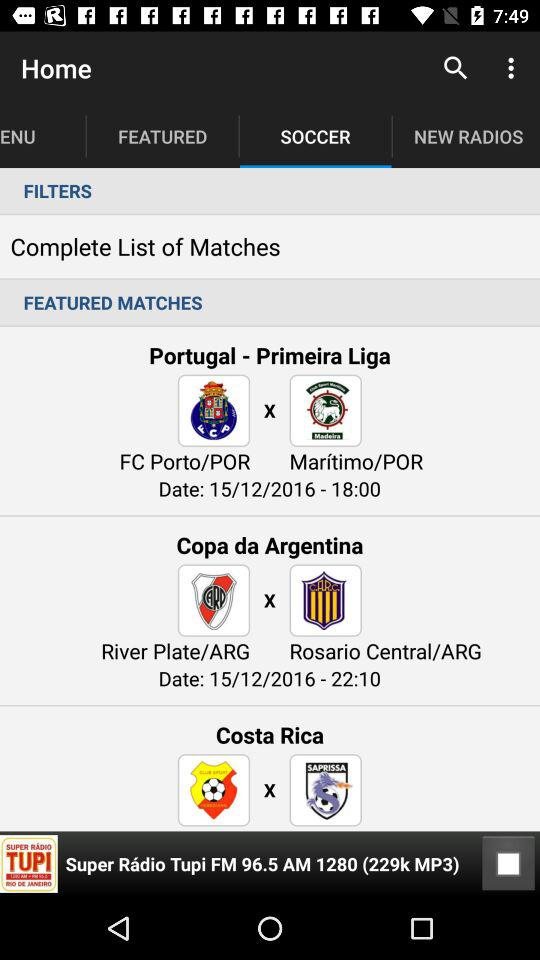What is the time of the matches? The times are 18:00 and 22:10. 